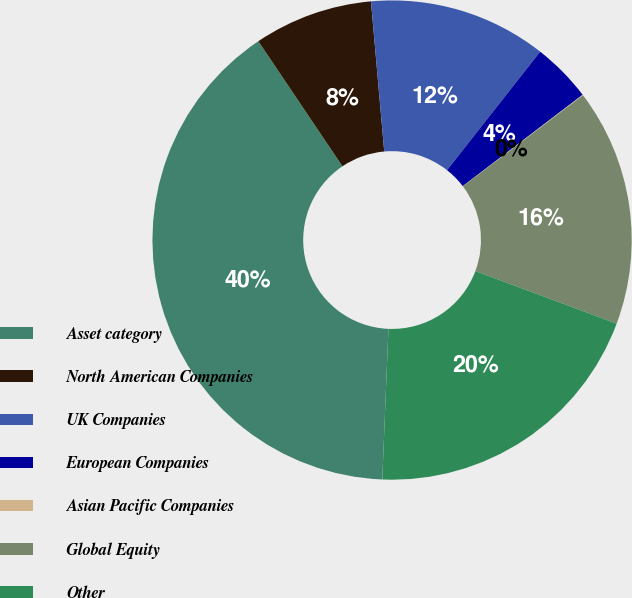Convert chart to OTSL. <chart><loc_0><loc_0><loc_500><loc_500><pie_chart><fcel>Asset category<fcel>North American Companies<fcel>UK Companies<fcel>European Companies<fcel>Asian Pacific Companies<fcel>Global Equity<fcel>Other<nl><fcel>39.93%<fcel>8.02%<fcel>12.01%<fcel>4.03%<fcel>0.04%<fcel>16.0%<fcel>19.98%<nl></chart> 